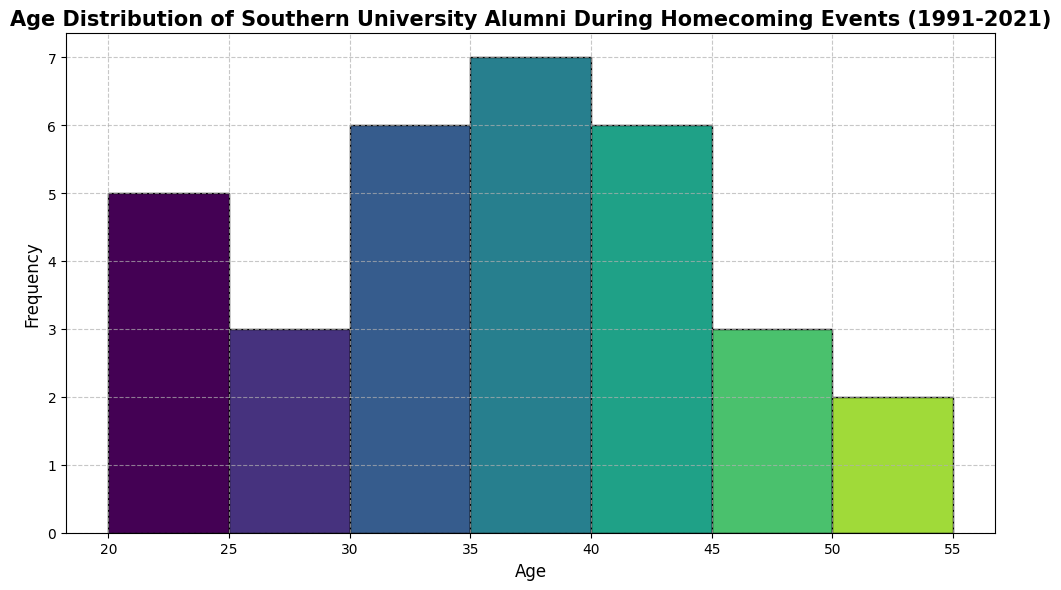Which age range has the highest frequency of alumni at the homecoming events? By observing the height of the bars in the histogram, which represent the frequency of alumni falling in each age range, the bar with the highest height corresponds to the age range with the highest frequency.
Answer: 35-40 How many alumni are in the 30-35 age range? Identify the bar representing the 30-35 age range and check its height to determine the frequency of alumni in that category.
Answer: 4 What’s the total number of alumni aged 40 and above? Add up the heights of all bars corresponding to the age ranges 40-45, 45-50, 50-55, and above. These bars collectively give the total number of alumni aged 40 and above.
Answer: 9 Compare the number of alumni in the 25-30 age range to the number in the 50-55 age range. Which is higher? Check the height of the bars corresponding to 25-30 and 50-55 age ranges and compare them to determine which is higher.
Answer: 25-30 Is there a more significant number of alumni in the 20-25 age range or the 55-60 age range? Observe the height of the bars corresponding to the 20-25 age range and the 55-60 age range and compare their heights.
Answer: 20-25 In which age range does the frequency sharply drop or increase between adjacent bins? Describe the transition. By scanning through the histogram, identify the age ranges where a sudden change in bar height occurs, indicating a sharp drop or increase in the number of alumni.
Answer: 40-45 to 45-50 (sharp increase) What’s the average frequency of alumni in all age ranges? Sum the frequencies of all age ranges and divide by the number of age ranges.
Answer: 3.2 Does any age range have a frequency exactly equal to 3? Examine the bars and find any bar whose height equals 3 to determine if such an age range exists.
Answer: Yes Between which two consecutive age ranges is the smallest change in the number of alumni? Identify the two adjacent age ranges where the difference in the height of the bars is minimal.
Answer: 30-35 and 35-40 Which decade (1991-2000, 2001-2010, etc.) has the most diversity in age distribution based on the histogram? Examine the histogram and consider the spread and height of bars corresponding to the alumni years to identify which decade has the most varied age distribution.
Answer: 2001-2010 